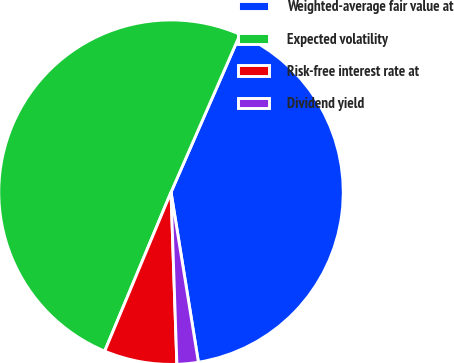<chart> <loc_0><loc_0><loc_500><loc_500><pie_chart><fcel>Weighted-average fair value at<fcel>Expected volatility<fcel>Risk-free interest rate at<fcel>Dividend yield<nl><fcel>40.89%<fcel>50.27%<fcel>6.83%<fcel>2.0%<nl></chart> 